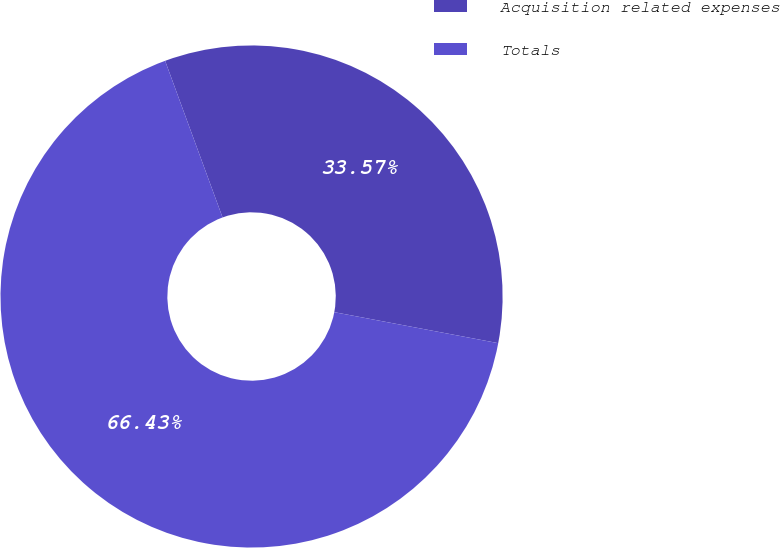Convert chart. <chart><loc_0><loc_0><loc_500><loc_500><pie_chart><fcel>Acquisition related expenses<fcel>Totals<nl><fcel>33.57%<fcel>66.43%<nl></chart> 